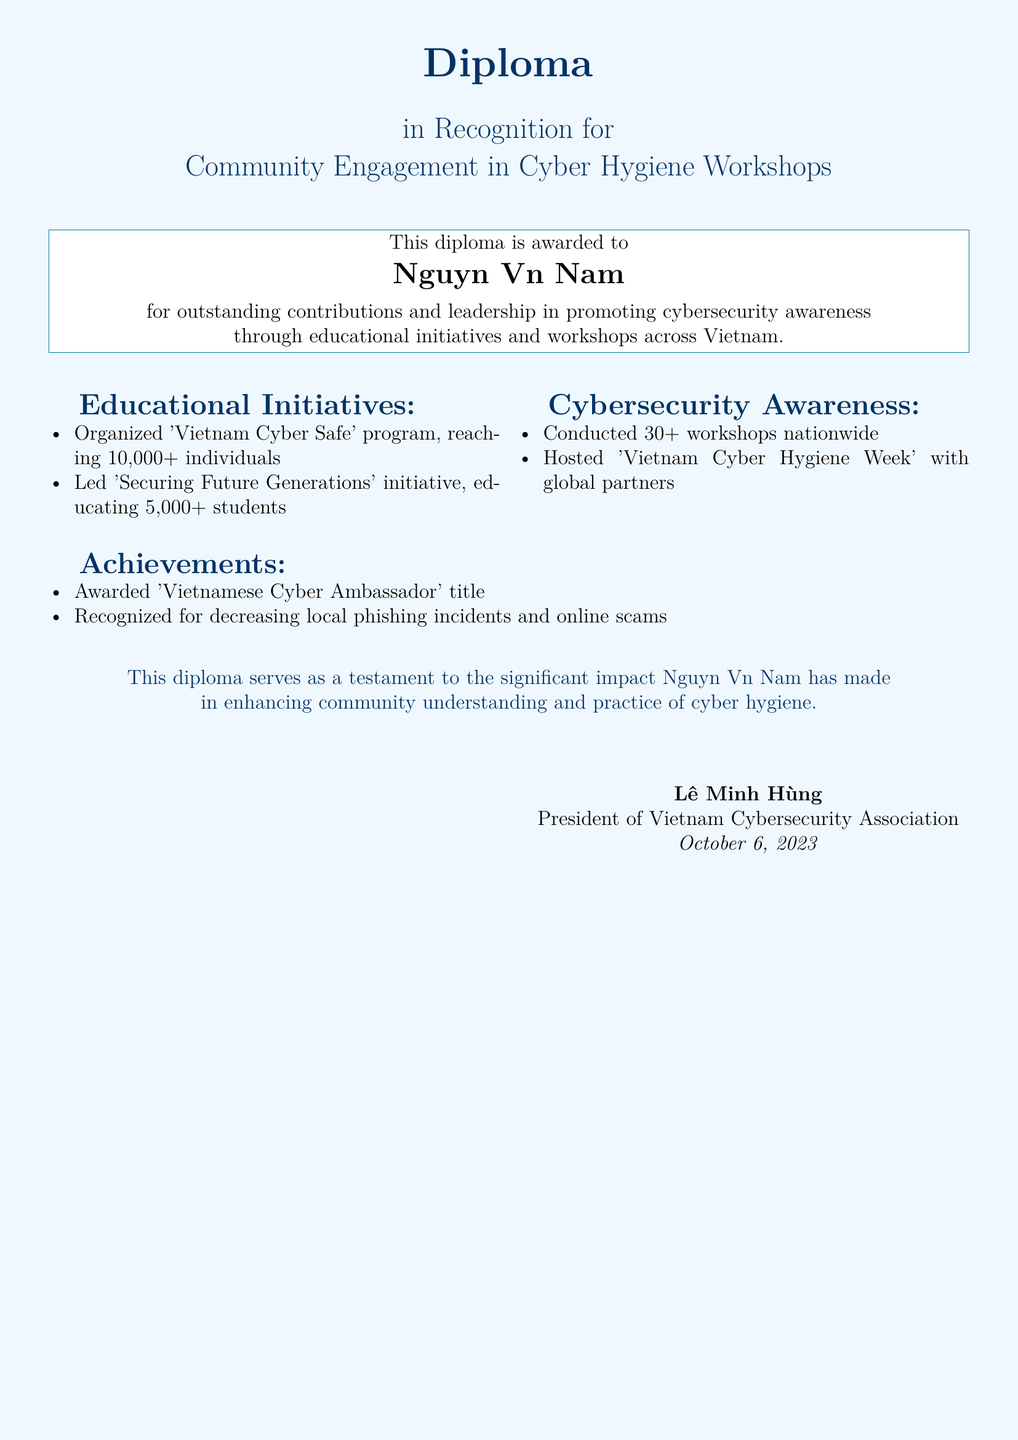What is the name of the recipient? The recipient's name is clearly stated in the diploma as Nguyễn Văn Nam.
Answer: Nguyễn Văn Nam What is the title awarded in this diploma? The title awarded in the diploma is explicitly mentioned as "Diploma in Recognition for Community Engagement in Cyber Hygiene Workshops."
Answer: Diploma in Recognition for Community Engagement in Cyber Hygiene Workshops How many individuals did the 'Vietnam Cyber Safe' program reach? The document specifies that the 'Vietnam Cyber Safe' program reached over 10,000 individuals.
Answer: 10,000+ How many workshops were conducted nationwide? According to the document, more than 30 workshops were conducted nationwide.
Answer: 30+ What initiative focused on educating students? The educational initiative aimed at students is identified in the document as 'Securing Future Generations'.
Answer: Securing Future Generations When was the diploma awarded? The date the diploma was issued is recorded as October 6, 2023.
Answer: October 6, 2023 Who is the signatory of the diploma? The diploma was signed by Lê Minh Hùng, as indicated in the document.
Answer: Lê Minh Hùng What was one significant recognition received by Nguyễn Văn Nam? The diploma mentions that he was awarded the 'Vietnamese Cyber Ambassador' title.
Answer: Vietnamese Cyber Ambassador What was the purpose of the 'Vietnam Cyber Hygiene Week'? The goal of the 'Vietnam Cyber Hygiene Week', mentioned in the diploma, was to promote cybersecurity awareness through global partnerships.
Answer: Promote cybersecurity awareness 